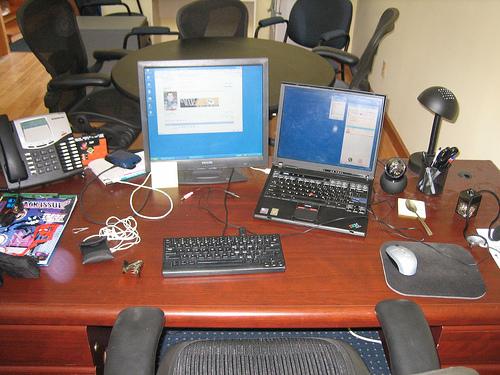How many computer screens are there?
Give a very brief answer. 2. Is the computer on?
Give a very brief answer. Yes. Is that a comic book on the left side?
Give a very brief answer. Yes. Which device has a USB port?
Write a very short answer. Laptop. 